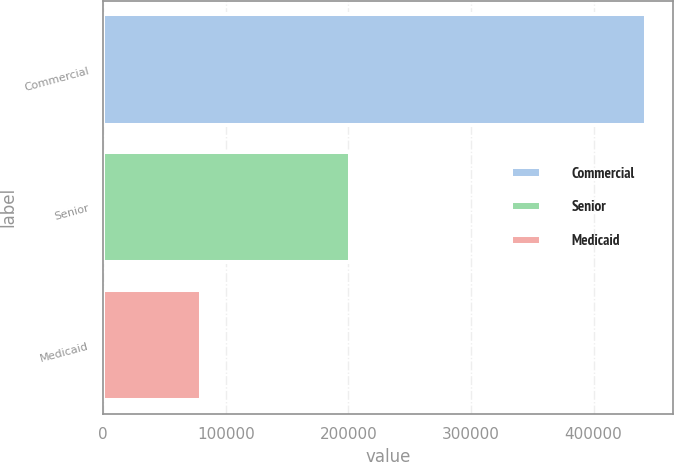Convert chart. <chart><loc_0><loc_0><loc_500><loc_500><bar_chart><fcel>Commercial<fcel>Senior<fcel>Medicaid<nl><fcel>442700<fcel>201300<fcel>80000<nl></chart> 